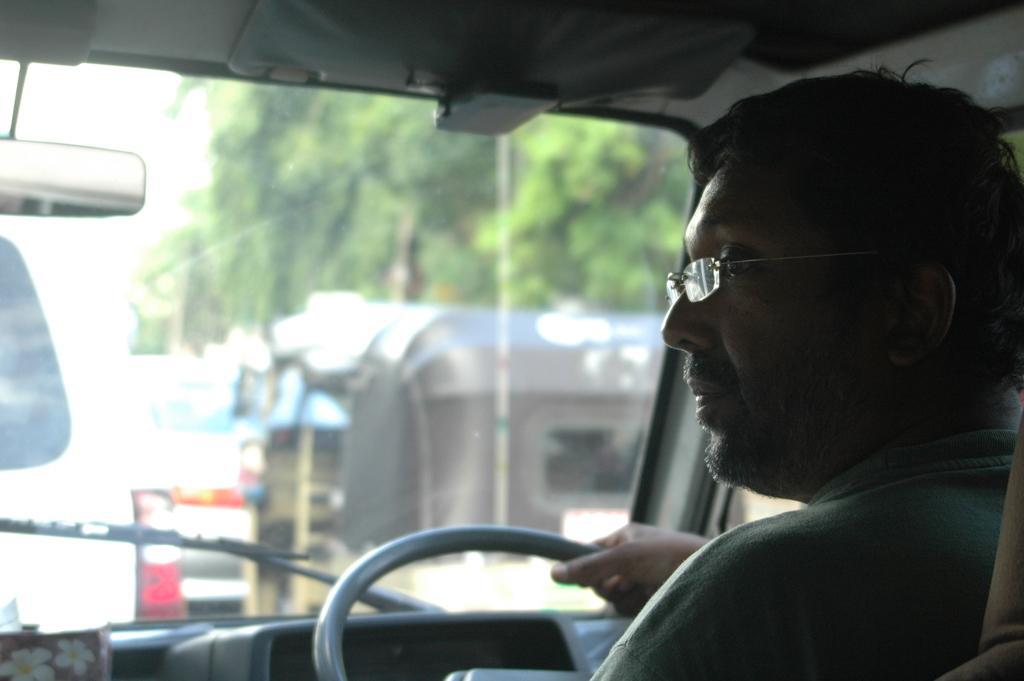In one or two sentences, can you explain what this image depicts? In the middle of the image there is a vehicle. Bottom right side of the image a man sitting on a vehicle. Throw the window we can see the trees. 